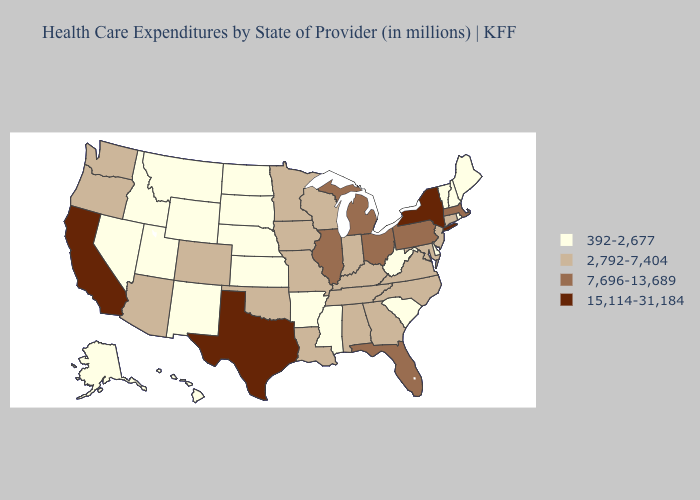Does Illinois have the lowest value in the USA?
Give a very brief answer. No. What is the value of Louisiana?
Give a very brief answer. 2,792-7,404. What is the lowest value in states that border Montana?
Quick response, please. 392-2,677. Does New York have the highest value in the Northeast?
Concise answer only. Yes. What is the value of Washington?
Keep it brief. 2,792-7,404. Name the states that have a value in the range 15,114-31,184?
Quick response, please. California, New York, Texas. Among the states that border Rhode Island , which have the highest value?
Write a very short answer. Massachusetts. Does Kansas have a lower value than Minnesota?
Keep it brief. Yes. What is the value of Georgia?
Short answer required. 2,792-7,404. Does New Hampshire have the highest value in the Northeast?
Answer briefly. No. Name the states that have a value in the range 392-2,677?
Concise answer only. Alaska, Arkansas, Delaware, Hawaii, Idaho, Kansas, Maine, Mississippi, Montana, Nebraska, Nevada, New Hampshire, New Mexico, North Dakota, Rhode Island, South Carolina, South Dakota, Utah, Vermont, West Virginia, Wyoming. What is the lowest value in states that border New Hampshire?
Answer briefly. 392-2,677. Does Connecticut have a lower value than Michigan?
Concise answer only. Yes. Is the legend a continuous bar?
Short answer required. No. Does Connecticut have a lower value than Massachusetts?
Give a very brief answer. Yes. 